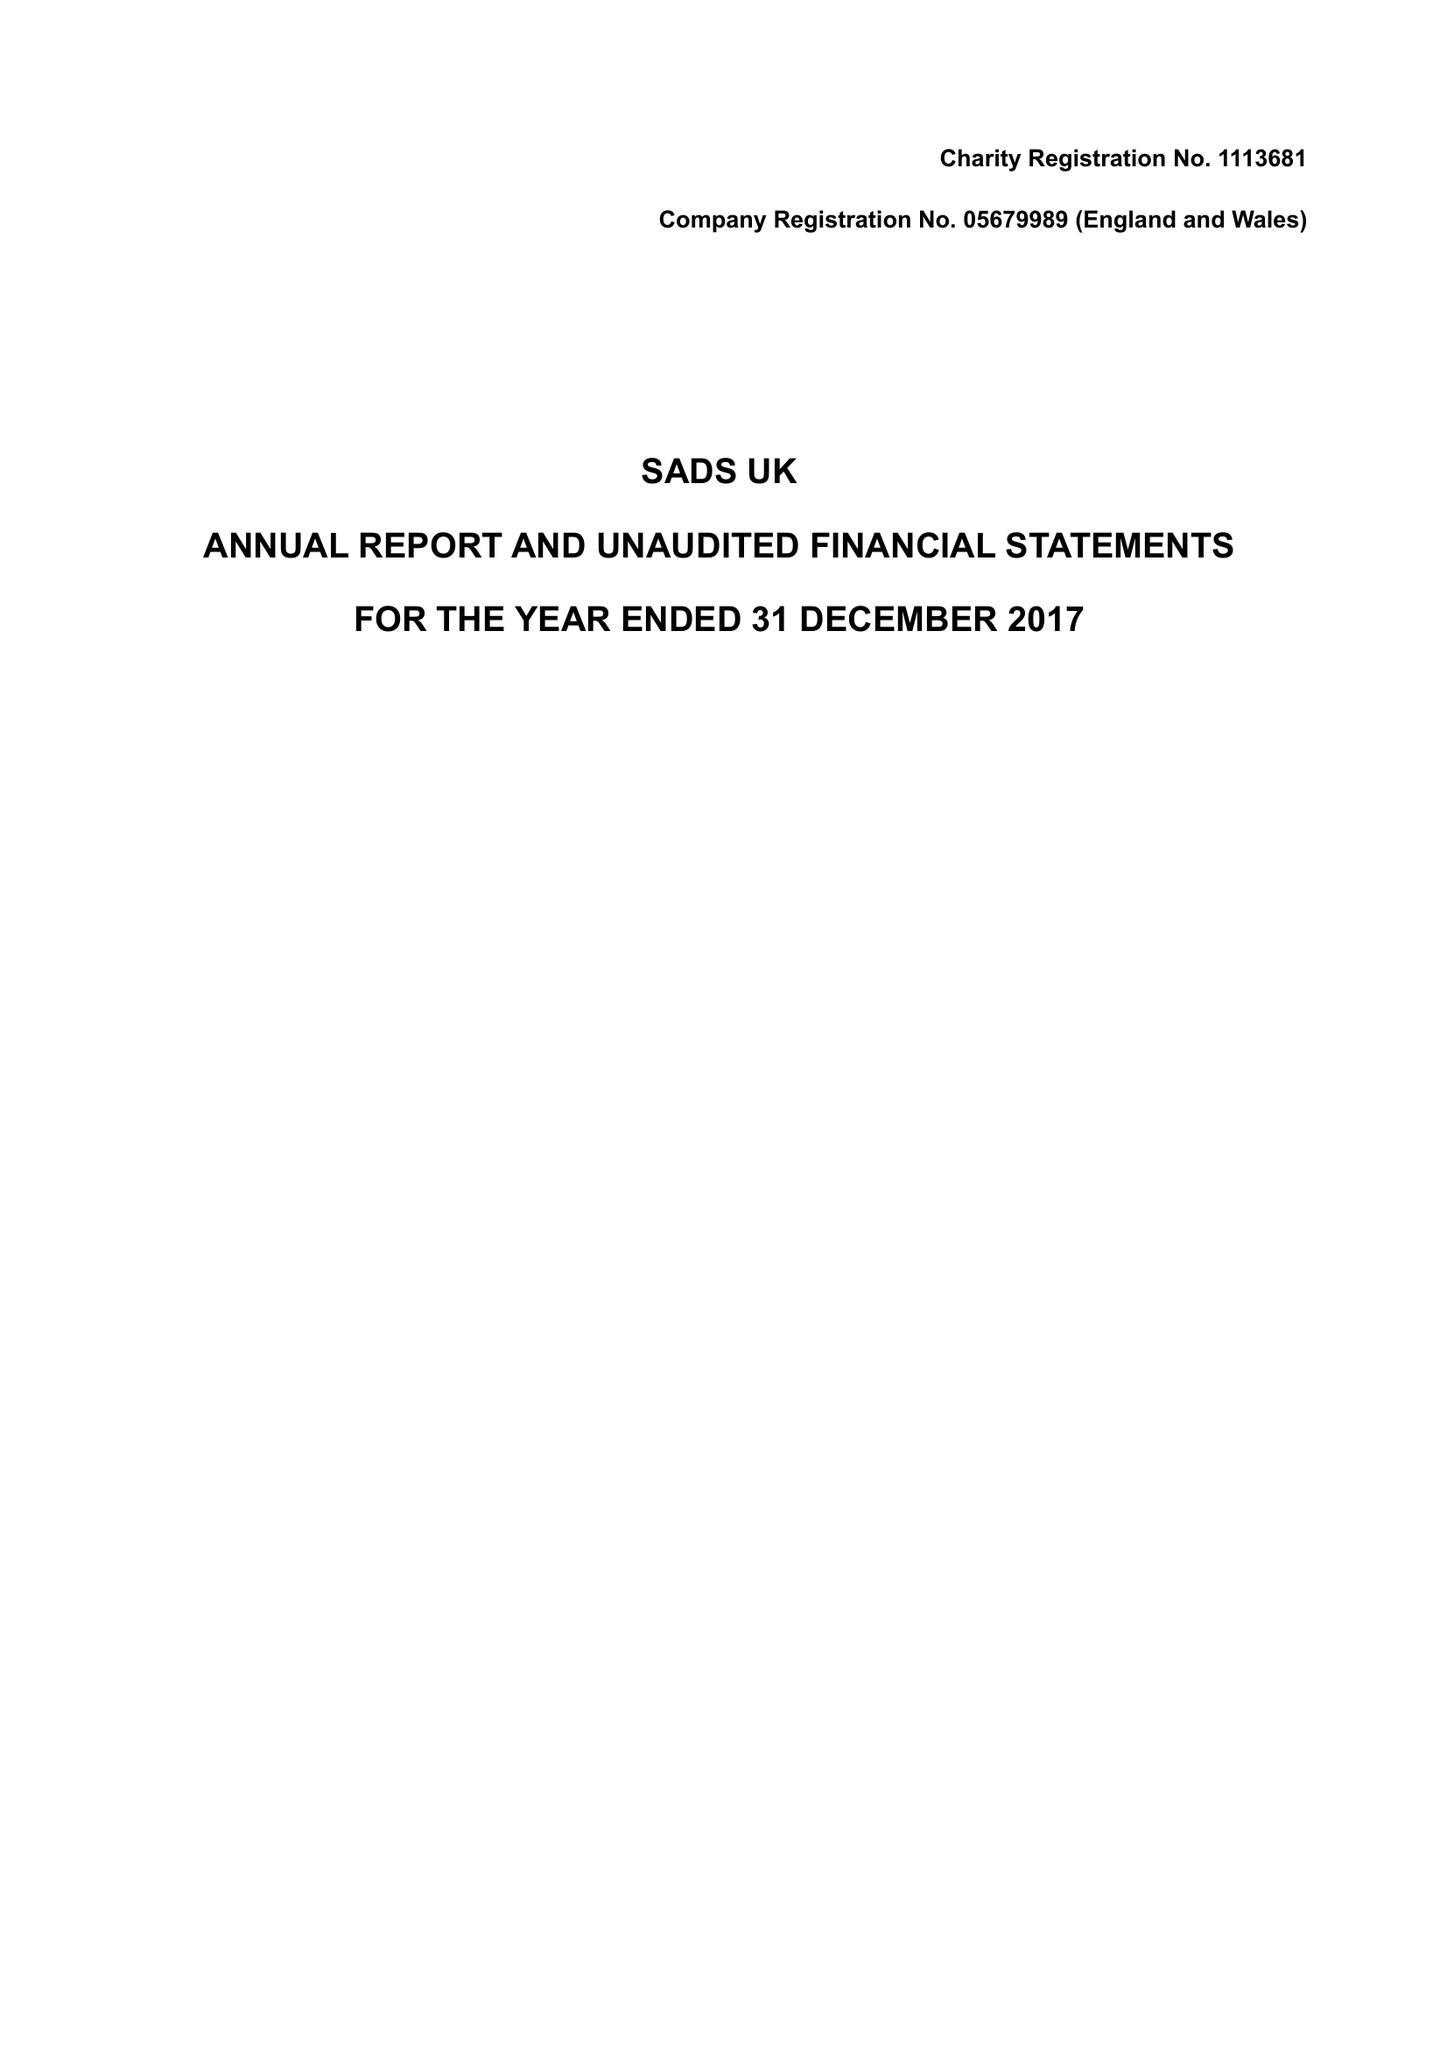What is the value for the spending_annually_in_british_pounds?
Answer the question using a single word or phrase. 389746.00 